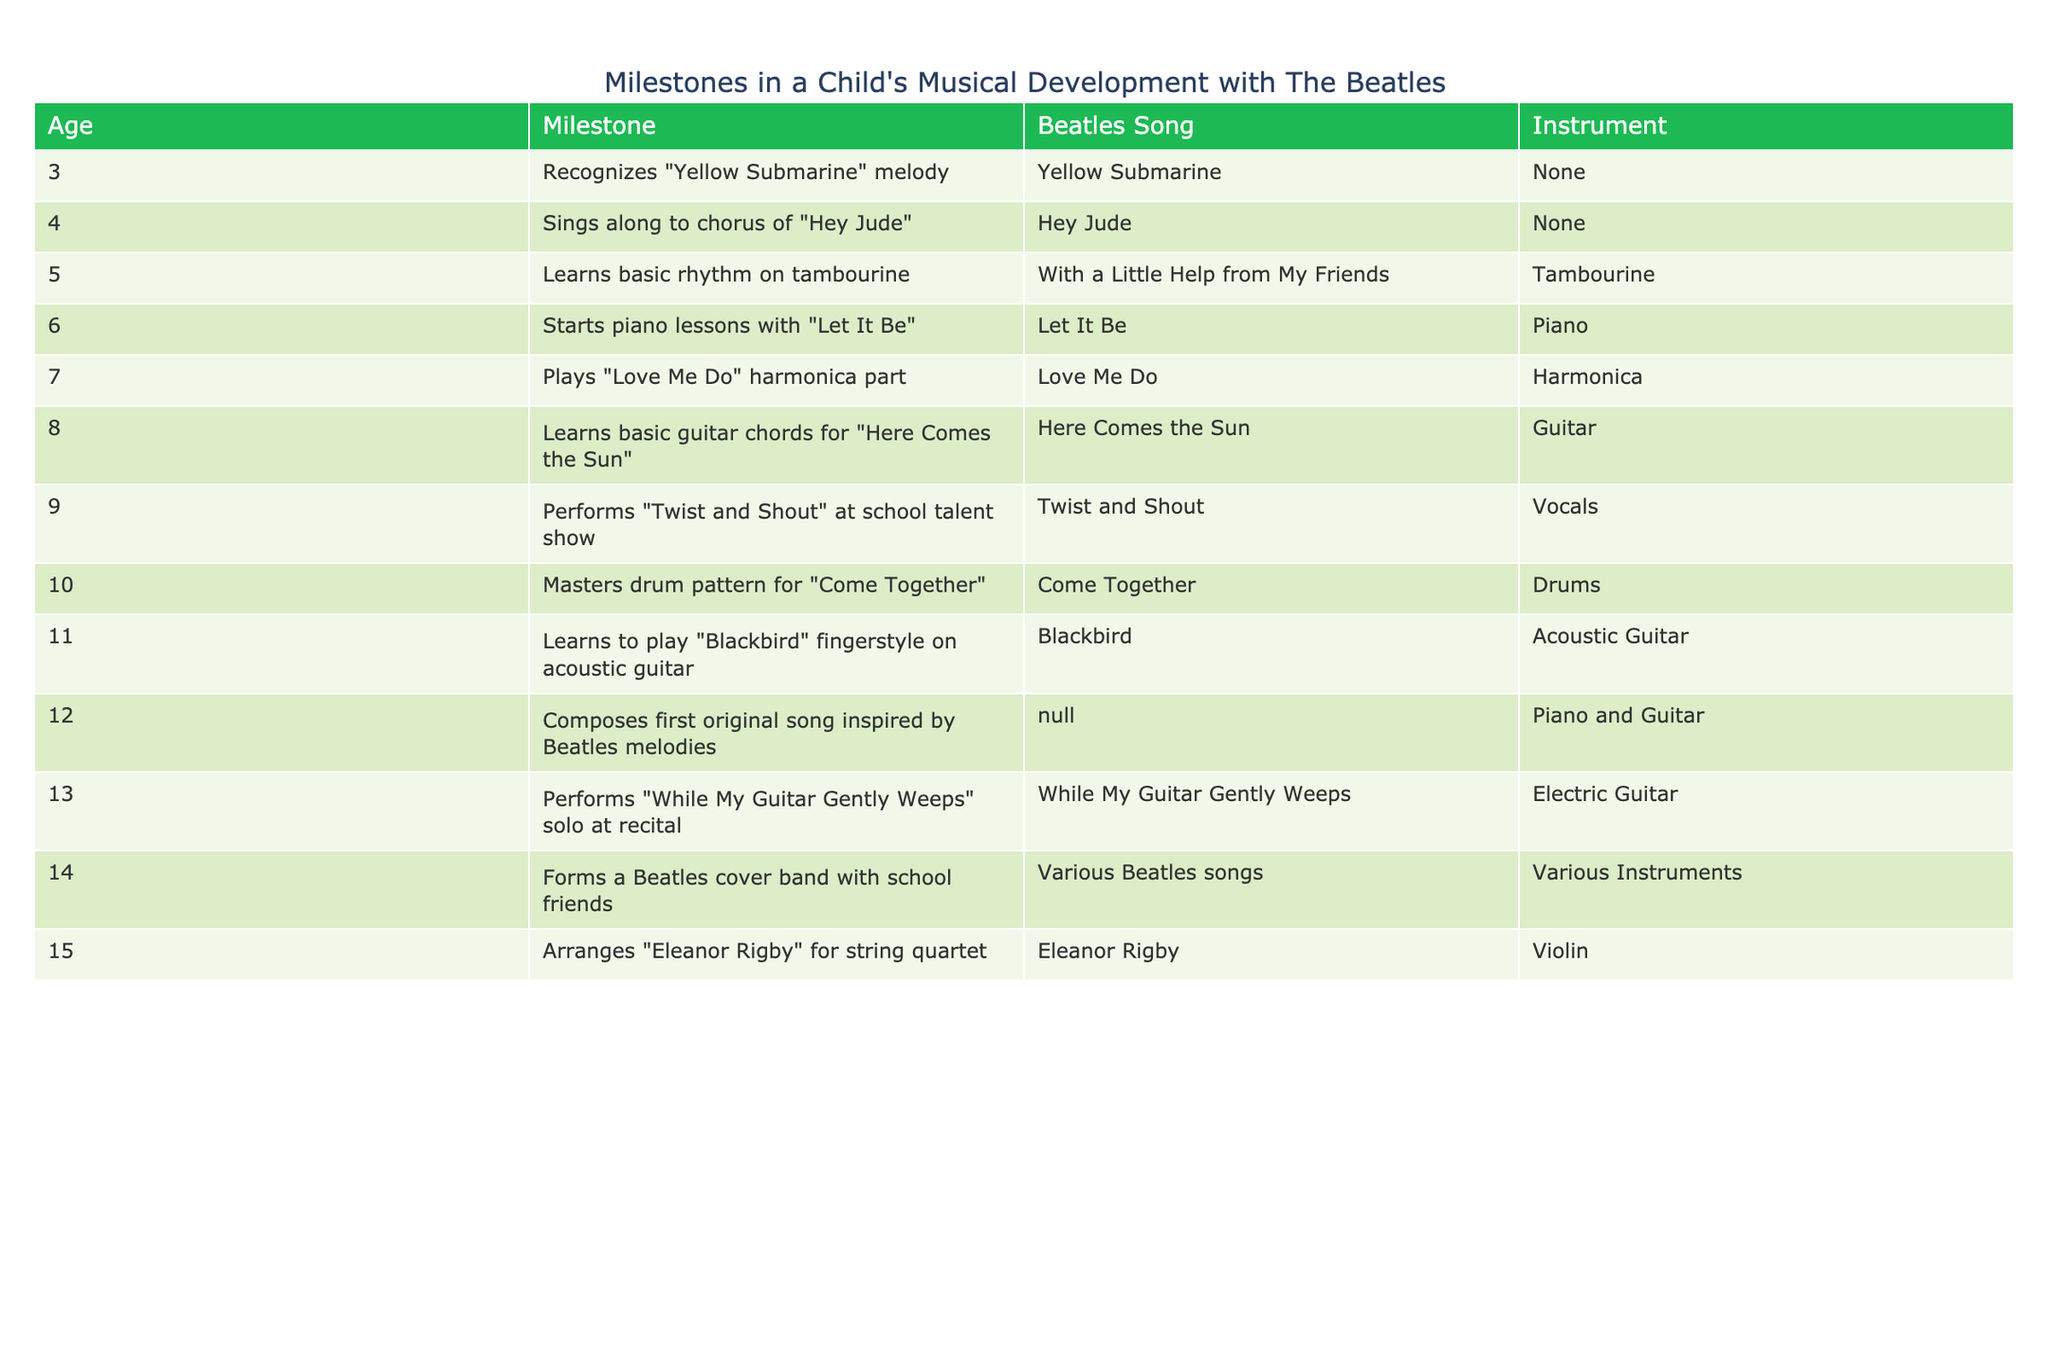What is the first Beatles song the child recognizes? The table lists the milestones in chronological order by age. At age 3, the milestone "Recognizes 'Yellow Submarine' melody" is mentioned, which indicates that this is the first Beatles song the child recognizes.
Answer: Yellow Submarine At what age does the child start piano lessons? By looking at the age column, the milestone for starting piano lessons is found at age 6 with the song "Let It Be." Thus, at age 6, the child starts piano lessons.
Answer: 6 How many different instruments does the child use by age 15? The table shows milestones up to age 15 and lists various instruments used. Instruments include Tambourine (age 5), Piano (age 6), Harmonica (age 7), Guitar (age 8), Drums (age 10), Acoustic Guitar (age 11), Electric Guitar (age 13), Violin (age 15), and "Various Instruments" in the band formed at age 14. Counting unique instruments reveals 6 distinct instruments: Tambourine, Piano, Harmonica, Guitar, Drums, Acoustic Guitar, Electric Guitar, and Violin.
Answer: 8 Did the child perform "Twist and Shout" before learning to play "Blackbird"? Checking the age milestones, "Twist and Shout" performance is recorded at age 9, while learning "Blackbird" is at age 11. Since age 9 is before age 11, the child did perform "Twist and Shout" first.
Answer: Yes What is the average age at which the child learns a new instrument? To find the average age for learning a new instrument, we take the ages listed for milestones directly related to learning instruments: 5 (Tambourine), 6 (Piano), 7 (Harmonica), 8 (Guitar), 10 (Drums), 11 (Acoustic Guitar), 13 (Electric Guitar), and 15 (Violin). The total is 5 + 6 + 7 + 8 + 10 + 11 + 13 + 15 = 75. Then, there are 8 learning milestones, so the average is 75 / 8 = 9.375. Rounding gives approximately 9.4 years old.
Answer: 9.4 What song inspires the child's first original composition? The milestone related to composing an original song is recorded at age 12. It states that the child "Composes first original song inspired by Beatles melodies," indicating that Beatles melodies inspire this composition, but the original song is unspecified. Therefore, the answer focuses on the inspiration rather than a specific song.
Answer: N/A 